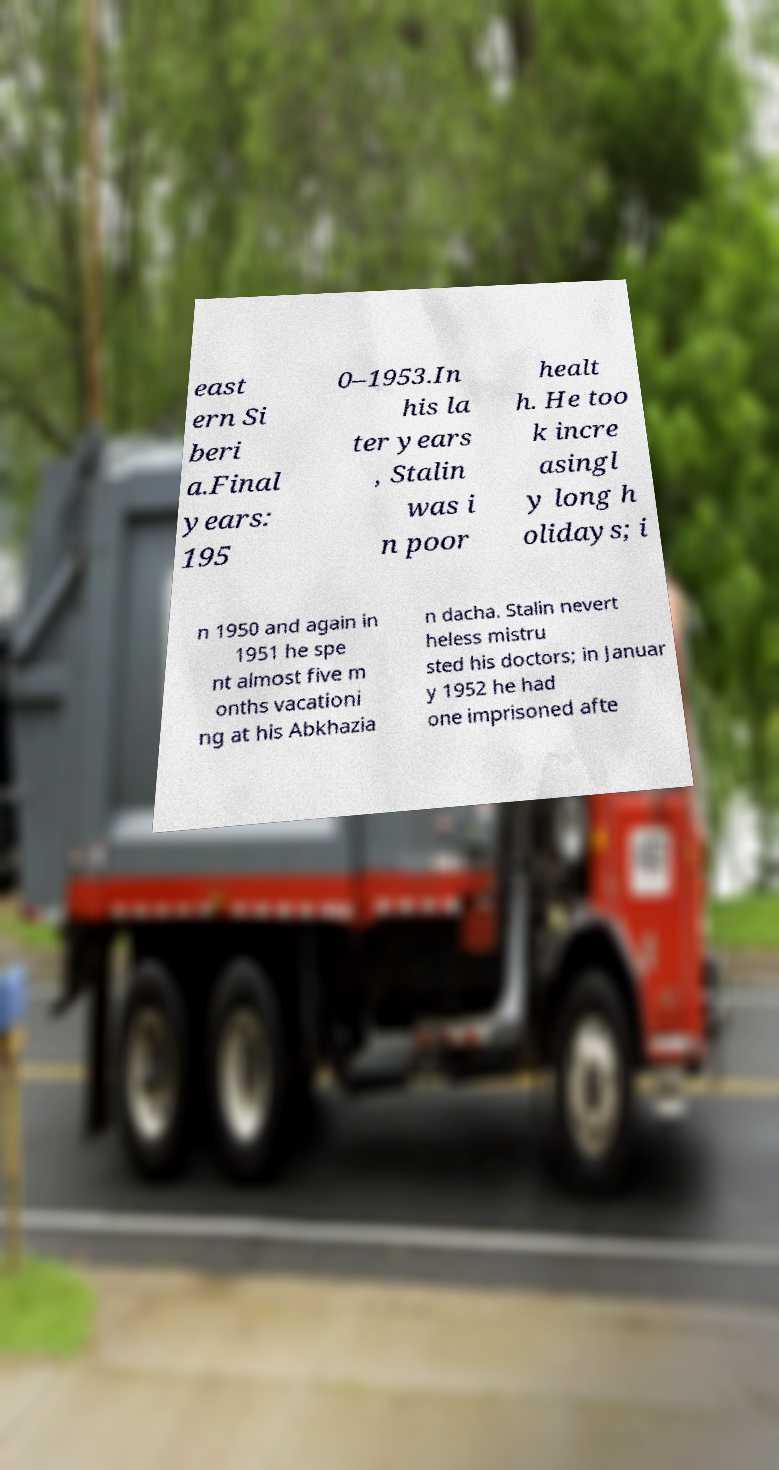Please identify and transcribe the text found in this image. east ern Si beri a.Final years: 195 0–1953.In his la ter years , Stalin was i n poor healt h. He too k incre asingl y long h olidays; i n 1950 and again in 1951 he spe nt almost five m onths vacationi ng at his Abkhazia n dacha. Stalin nevert heless mistru sted his doctors; in Januar y 1952 he had one imprisoned afte 